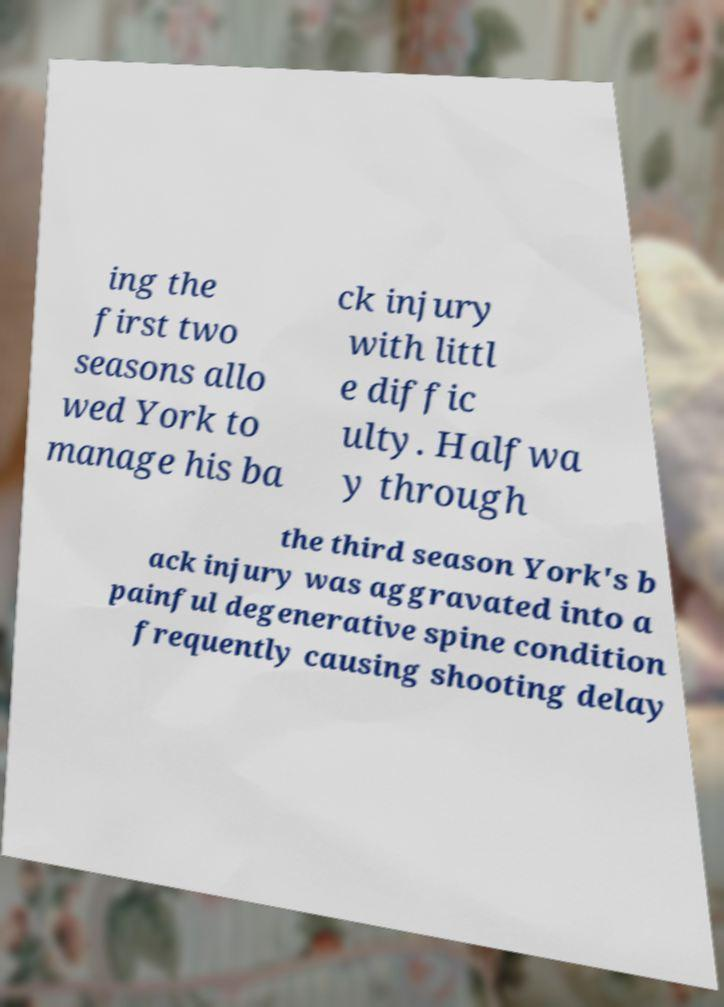What messages or text are displayed in this image? I need them in a readable, typed format. ing the first two seasons allo wed York to manage his ba ck injury with littl e diffic ulty. Halfwa y through the third season York's b ack injury was aggravated into a painful degenerative spine condition frequently causing shooting delay 